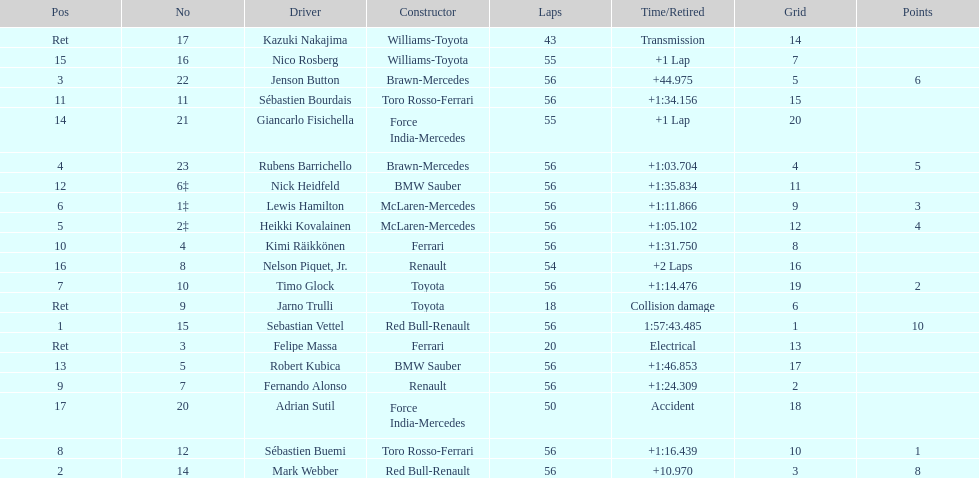Could you parse the entire table? {'header': ['Pos', 'No', 'Driver', 'Constructor', 'Laps', 'Time/Retired', 'Grid', 'Points'], 'rows': [['Ret', '17', 'Kazuki Nakajima', 'Williams-Toyota', '43', 'Transmission', '14', ''], ['15', '16', 'Nico Rosberg', 'Williams-Toyota', '55', '+1 Lap', '7', ''], ['3', '22', 'Jenson Button', 'Brawn-Mercedes', '56', '+44.975', '5', '6'], ['11', '11', 'Sébastien Bourdais', 'Toro Rosso-Ferrari', '56', '+1:34.156', '15', ''], ['14', '21', 'Giancarlo Fisichella', 'Force India-Mercedes', '55', '+1 Lap', '20', ''], ['4', '23', 'Rubens Barrichello', 'Brawn-Mercedes', '56', '+1:03.704', '4', '5'], ['12', '6‡', 'Nick Heidfeld', 'BMW Sauber', '56', '+1:35.834', '11', ''], ['6', '1‡', 'Lewis Hamilton', 'McLaren-Mercedes', '56', '+1:11.866', '9', '3'], ['5', '2‡', 'Heikki Kovalainen', 'McLaren-Mercedes', '56', '+1:05.102', '12', '4'], ['10', '4', 'Kimi Räikkönen', 'Ferrari', '56', '+1:31.750', '8', ''], ['16', '8', 'Nelson Piquet, Jr.', 'Renault', '54', '+2 Laps', '16', ''], ['7', '10', 'Timo Glock', 'Toyota', '56', '+1:14.476', '19', '2'], ['Ret', '9', 'Jarno Trulli', 'Toyota', '18', 'Collision damage', '6', ''], ['1', '15', 'Sebastian Vettel', 'Red Bull-Renault', '56', '1:57:43.485', '1', '10'], ['Ret', '3', 'Felipe Massa', 'Ferrari', '20', 'Electrical', '13', ''], ['13', '5', 'Robert Kubica', 'BMW Sauber', '56', '+1:46.853', '17', ''], ['9', '7', 'Fernando Alonso', 'Renault', '56', '+1:24.309', '2', ''], ['17', '20', 'Adrian Sutil', 'Force India-Mercedes', '50', 'Accident', '18', ''], ['8', '12', 'Sébastien Buemi', 'Toro Rosso-Ferrari', '56', '+1:16.439', '10', '1'], ['2', '14', 'Mark Webber', 'Red Bull-Renault', '56', '+10.970', '3', '8']]} What driver was last on the list? Jarno Trulli. 